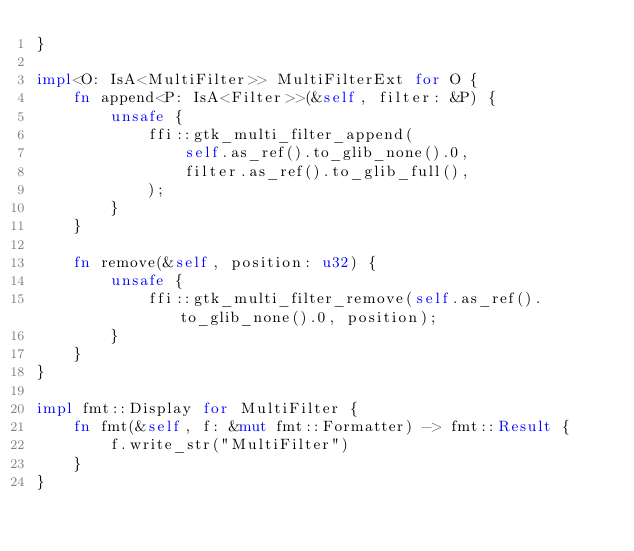Convert code to text. <code><loc_0><loc_0><loc_500><loc_500><_Rust_>}

impl<O: IsA<MultiFilter>> MultiFilterExt for O {
    fn append<P: IsA<Filter>>(&self, filter: &P) {
        unsafe {
            ffi::gtk_multi_filter_append(
                self.as_ref().to_glib_none().0,
                filter.as_ref().to_glib_full(),
            );
        }
    }

    fn remove(&self, position: u32) {
        unsafe {
            ffi::gtk_multi_filter_remove(self.as_ref().to_glib_none().0, position);
        }
    }
}

impl fmt::Display for MultiFilter {
    fn fmt(&self, f: &mut fmt::Formatter) -> fmt::Result {
        f.write_str("MultiFilter")
    }
}
</code> 